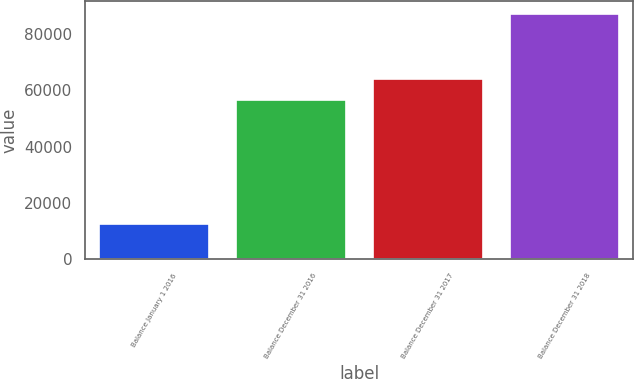Convert chart to OTSL. <chart><loc_0><loc_0><loc_500><loc_500><bar_chart><fcel>Balance January 1 2016<fcel>Balance December 31 2016<fcel>Balance December 31 2017<fcel>Balance December 31 2018<nl><fcel>12357<fcel>56635<fcel>64128.7<fcel>87294<nl></chart> 